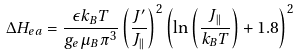<formula> <loc_0><loc_0><loc_500><loc_500>\Delta H _ { e a } = \frac { \epsilon k _ { B } T } { g _ { e } \mu _ { B } \pi ^ { 3 } } \left ( \frac { J ^ { \prime } } { J _ { \| } } \right ) ^ { 2 } \left ( \ln \left ( \frac { J _ { \| } } { k _ { B } T } \right ) + 1 . 8 \right ) ^ { 2 }</formula> 